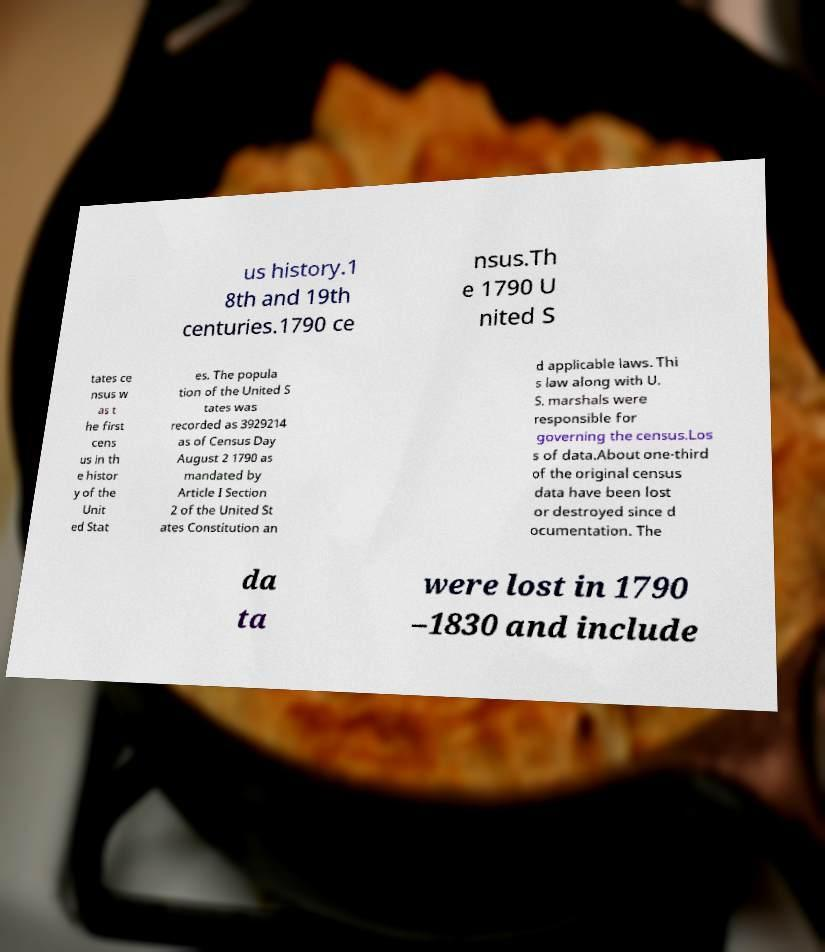There's text embedded in this image that I need extracted. Can you transcribe it verbatim? us history.1 8th and 19th centuries.1790 ce nsus.Th e 1790 U nited S tates ce nsus w as t he first cens us in th e histor y of the Unit ed Stat es. The popula tion of the United S tates was recorded as 3929214 as of Census Day August 2 1790 as mandated by Article I Section 2 of the United St ates Constitution an d applicable laws. Thi s law along with U. S. marshals were responsible for governing the census.Los s of data.About one-third of the original census data have been lost or destroyed since d ocumentation. The da ta were lost in 1790 –1830 and include 